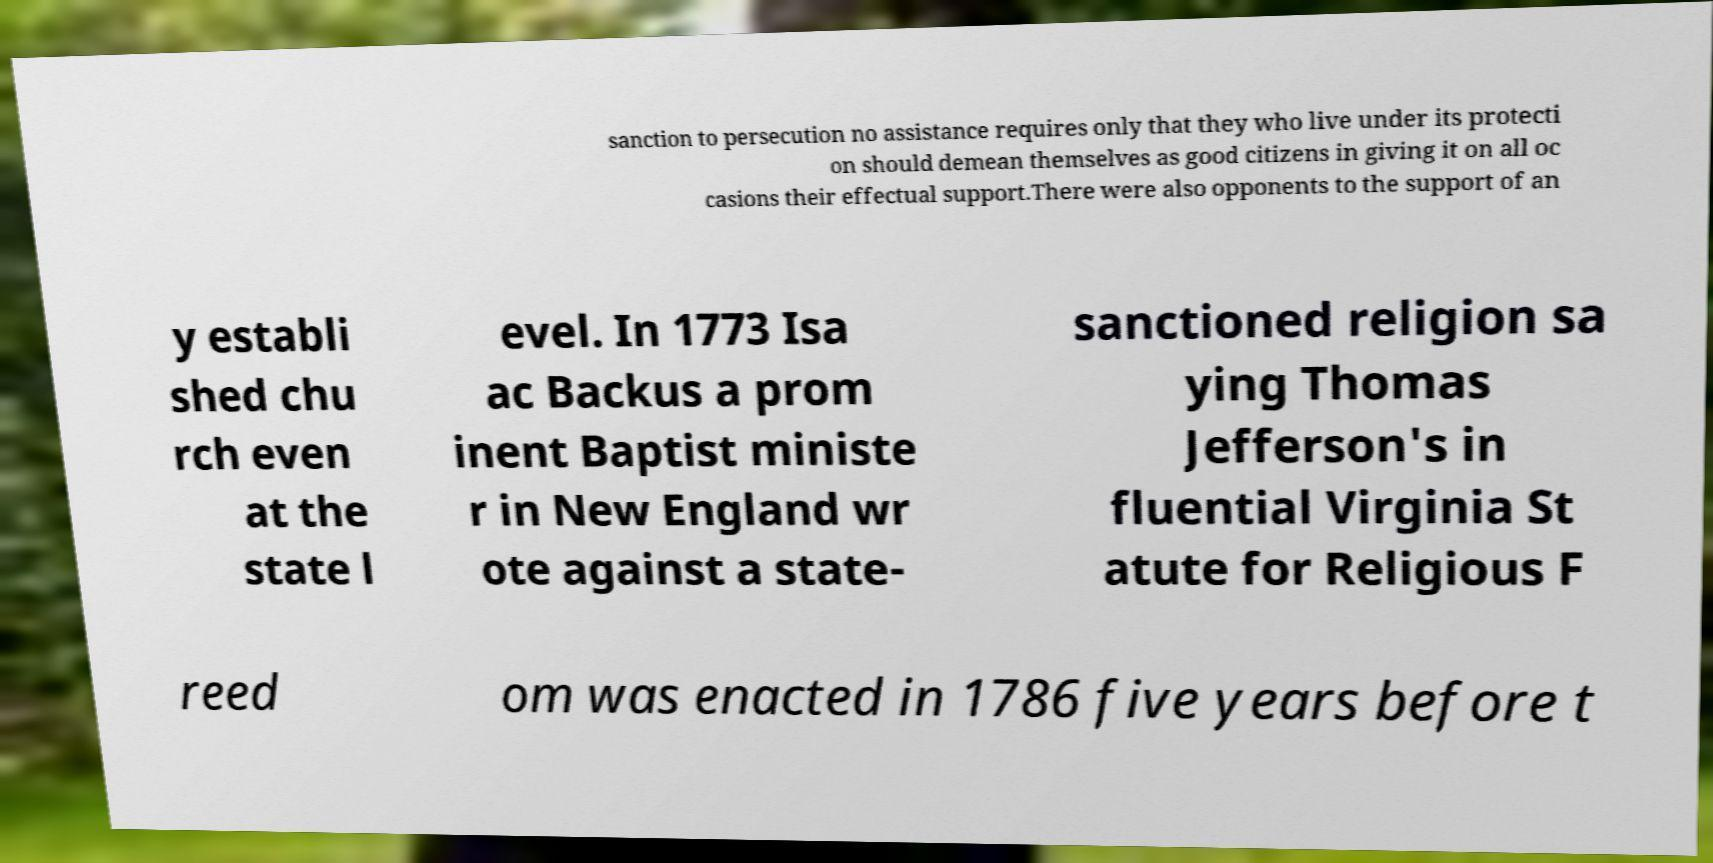Can you accurately transcribe the text from the provided image for me? sanction to persecution no assistance requires only that they who live under its protecti on should demean themselves as good citizens in giving it on all oc casions their effectual support.There were also opponents to the support of an y establi shed chu rch even at the state l evel. In 1773 Isa ac Backus a prom inent Baptist ministe r in New England wr ote against a state- sanctioned religion sa ying Thomas Jefferson's in fluential Virginia St atute for Religious F reed om was enacted in 1786 five years before t 